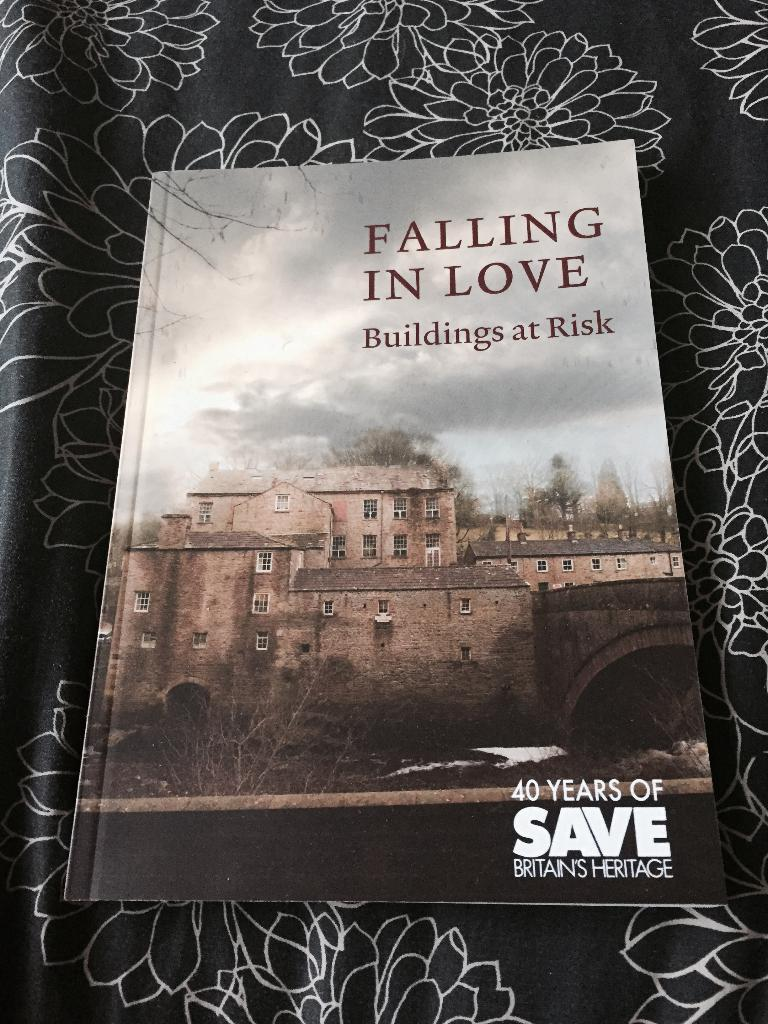<image>
Present a compact description of the photo's key features. A book about buildings at risk aims to inform readers by saving Britain's Heritage. 